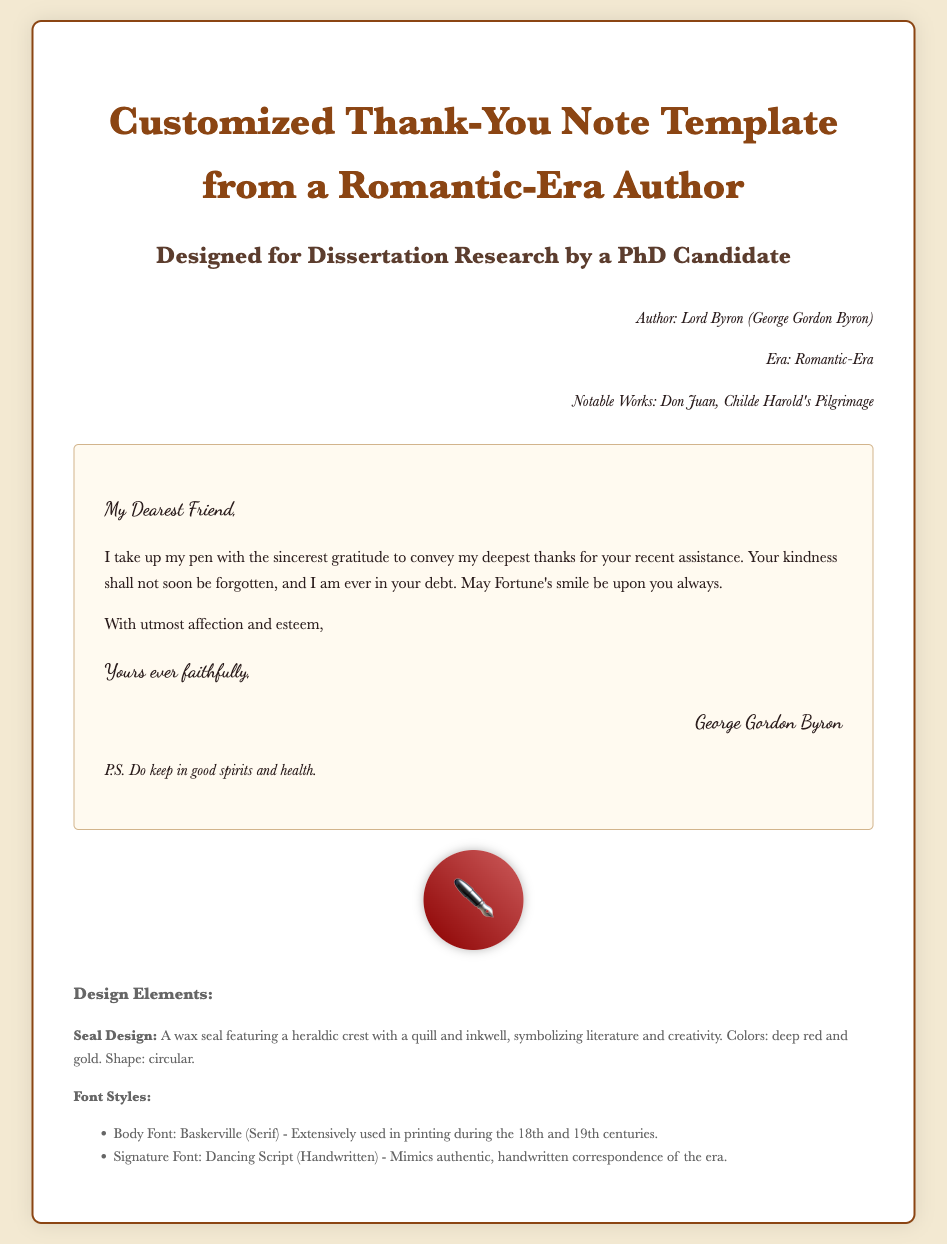What is the title of the template? The title of the template is stated at the top of the document, which identifies the type and purpose of the template.
Answer: Customized Thank-You Note Template from a Romantic-Era Author Who is the author of the note? The author is mentioned in the author information section, which also includes additional details about their background.
Answer: Lord Byron What font is used for the body text? The font used for the body text is specified in the style section of the document, showcasing the literary style of the Romantic era.
Answer: Baskerville What is the closing phrase of the note? The closing phrase indicates the author's respectful farewell and is typically included in letters from this period.
Answer: Yours ever faithfully What color is the seal design? The seal design color is described in the design elements section, highlighting the aesthetic qualities of the note.
Answer: deep red and gold What does the wax seal symbolize? The symbolism of the wax seal is mentioned in the design elements, reflecting the theme of the note.
Answer: literature and creativity Who is the note addressed to? The salutation at the beginning of the note provides insight into the recipient of the message and the nature of the relationship.
Answer: My Dearest Friend What element is featured in the seal design? The design of the seal is specifically mentioned, emphasizing its artistic and thematic importance.
Answer: a quill and inkwell What is the postscript of the note? The postscript adds a personal touch and further expresses the author's sentiments beyond the main content.
Answer: Do keep in good spirits and health 